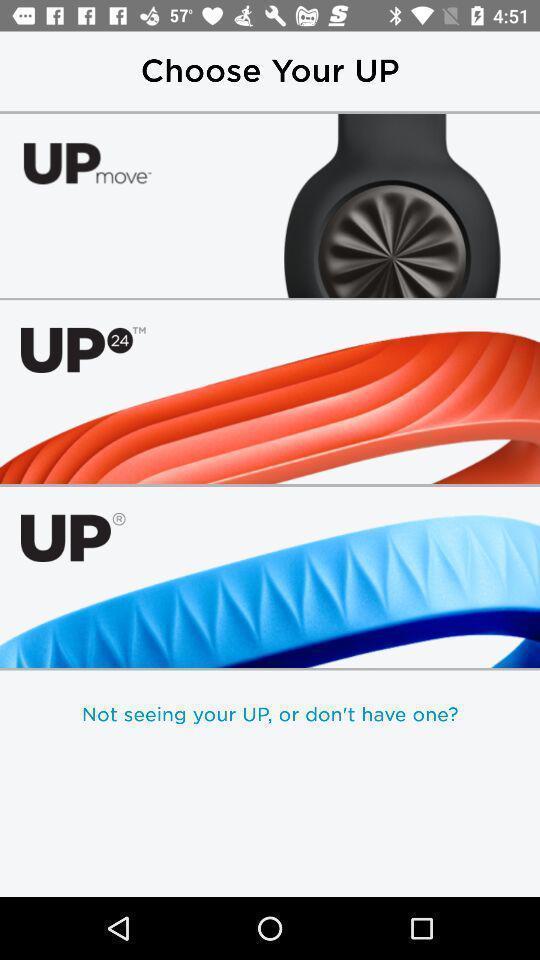Summarize the information in this screenshot. Screen displaying the screen page. 